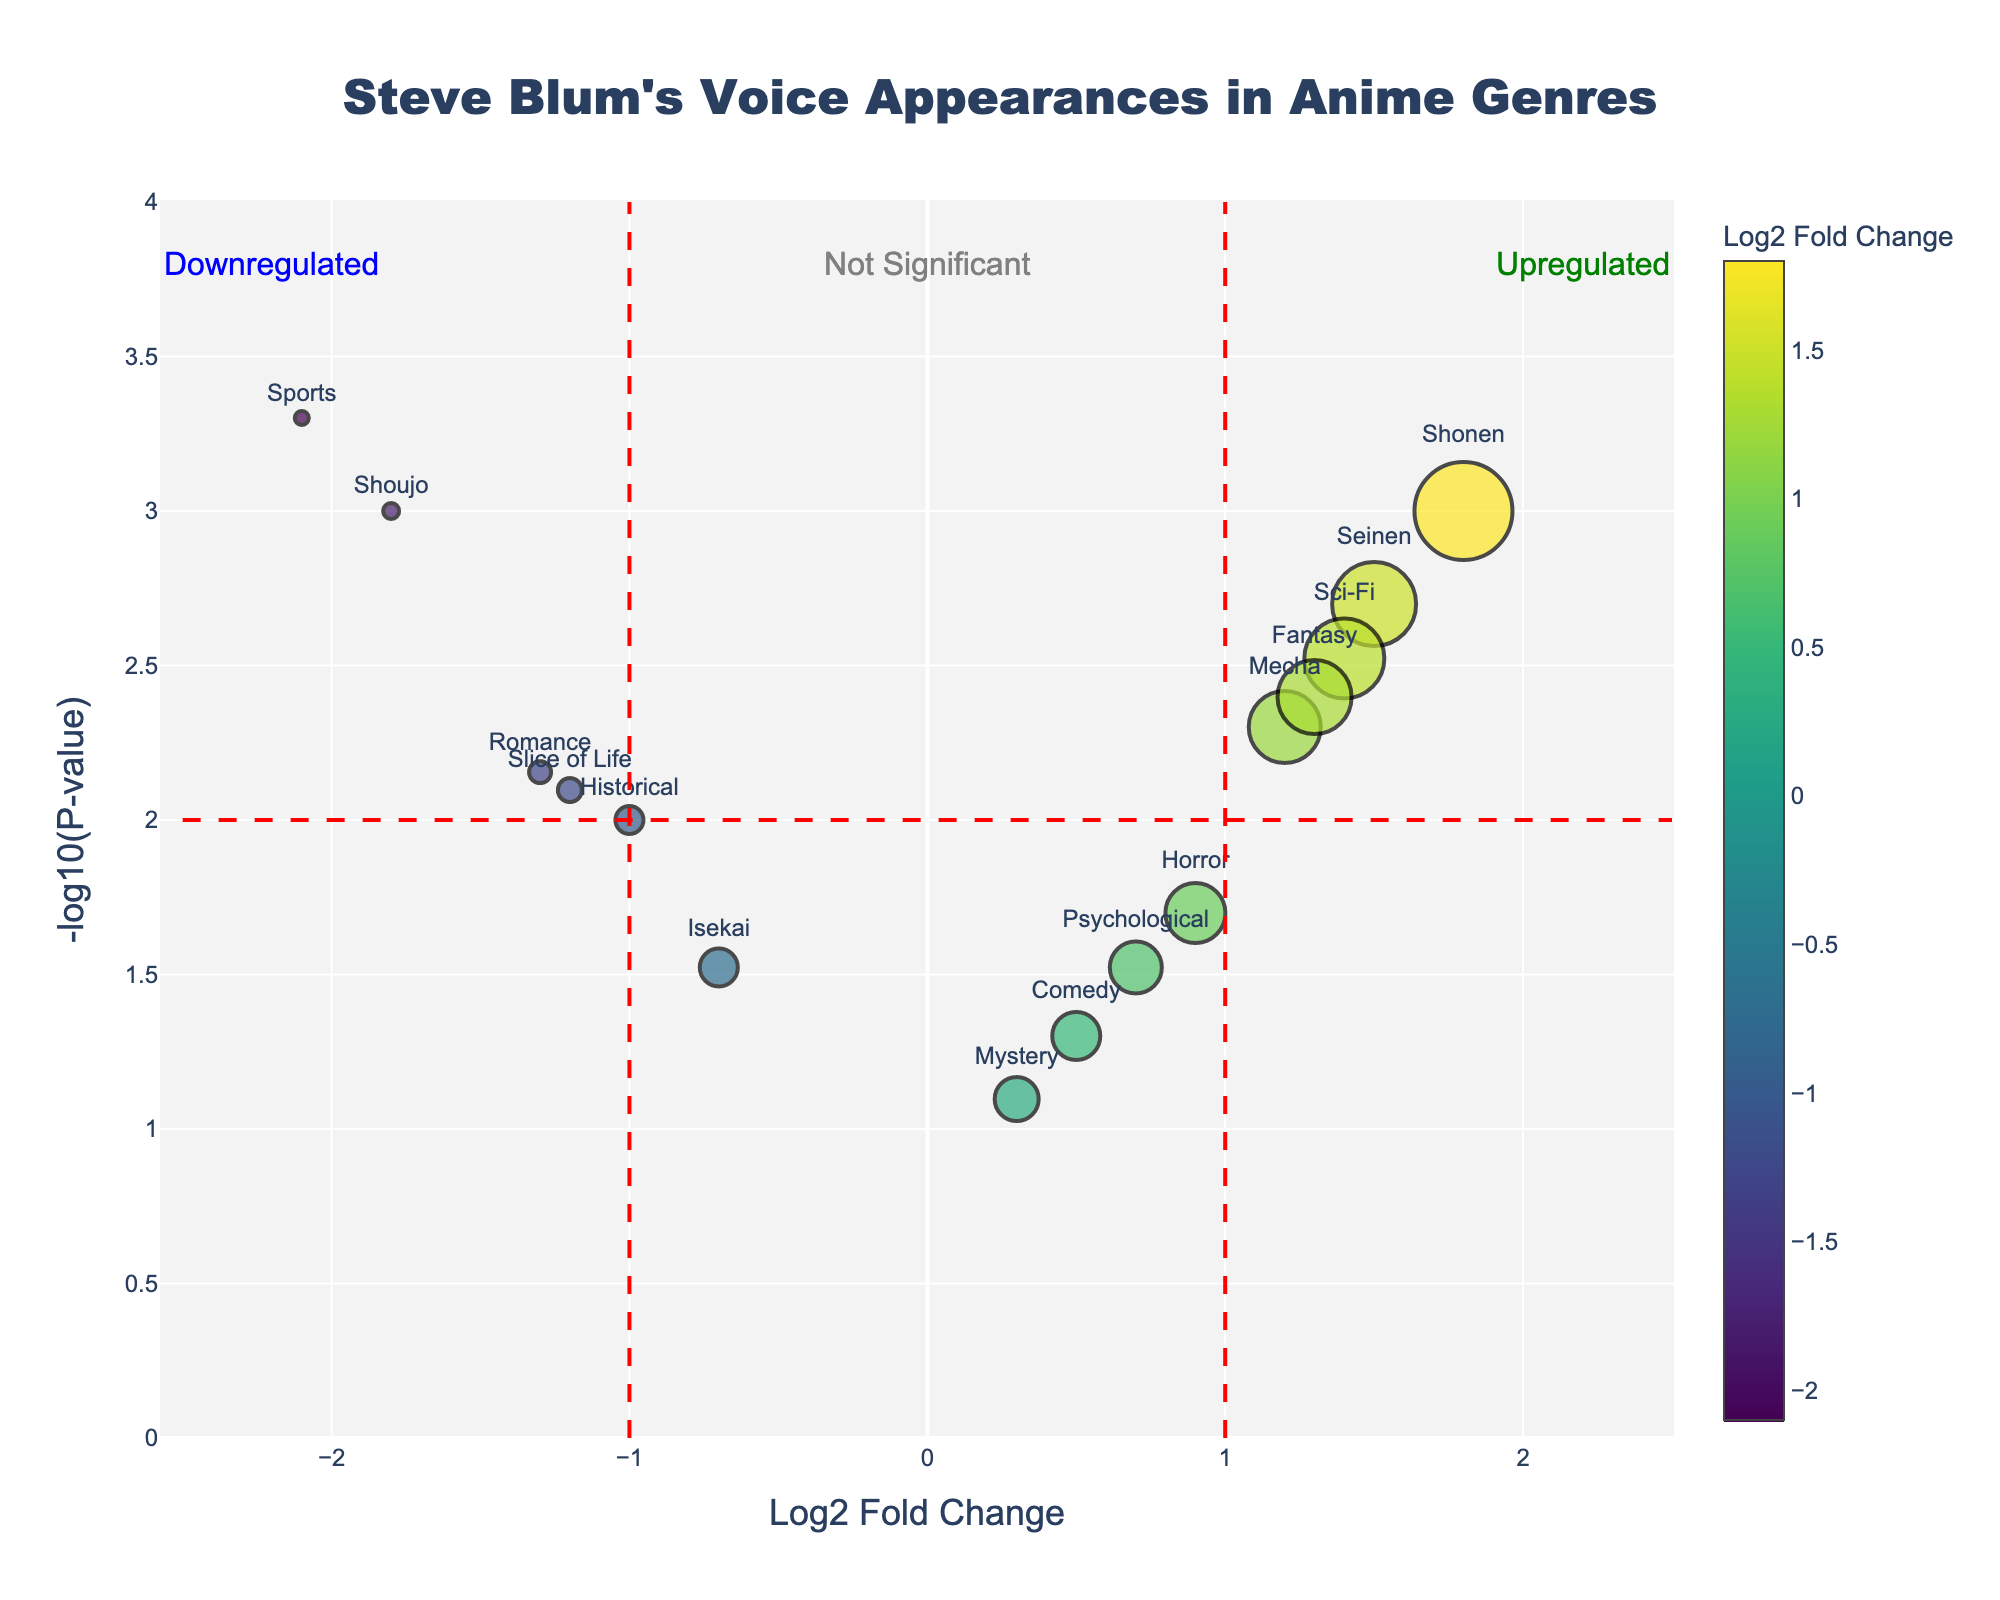What's the title of the plot? To find the title of the plot, look at the top center of the figure.
Answer: Steve Blum's Voice Appearances in Anime Genres What does the x-axis represent? The x-axis indicates the Log2 Fold Change, which measures the change in frequency of appearances.
Answer: Log2 Fold Change Which genre has the highest number of appearances? By looking at the sizes of the markers, the largest corresponds to the genre with the highest number of appearances, namely Shonen.
Answer: Shonen Which genres are considered upregulated based on their Log2FoldChange? Genres with Log2FoldChange greater than 1 are considered upregulated. Look for genres with Log2FoldChange values positioned to the right of the vertical red dashed line at 1.
Answer: Shonen, Seinen, Sci-Fi, Fantasy How many genres fall into the "Not Significant" category? "Not Significant" categories are those with -log10(P-value) less than 2. Count the number of genres within this -log10(P-value) range.
Answer: 3 Which genre appears least frequently in the list? The smallest marker on the plot corresponds to the genre with the fewest appearances, which is Sports.
Answer: Sports Which genres are downregulated and significant? Downregulated and significant genres have a Log2FoldChange less than -1 and a -log10(P-value) greater than 2. Specifically look for genres to the left of -1 and above the horizontal red line at 2.
Answer: Shoujo, Slice of Life, Romance, Sports What threshold for -log10(P-value) separates significant from not significant observations? The horizontal red dashed line at y-axis indicates the threshold for significance.
Answer: 2 Compare the Log2FoldChange of Mecha and Horror genres. Which one is higher? Look at the x-axis positions for Mecha and Horror; the Log2FoldChange is higher for the genre farther right.
Answer: Mecha How many genres show a negative Log2FoldChange? Count the markers positioned on the left side of the vertical axis (negative x-values).
Answer: 6 